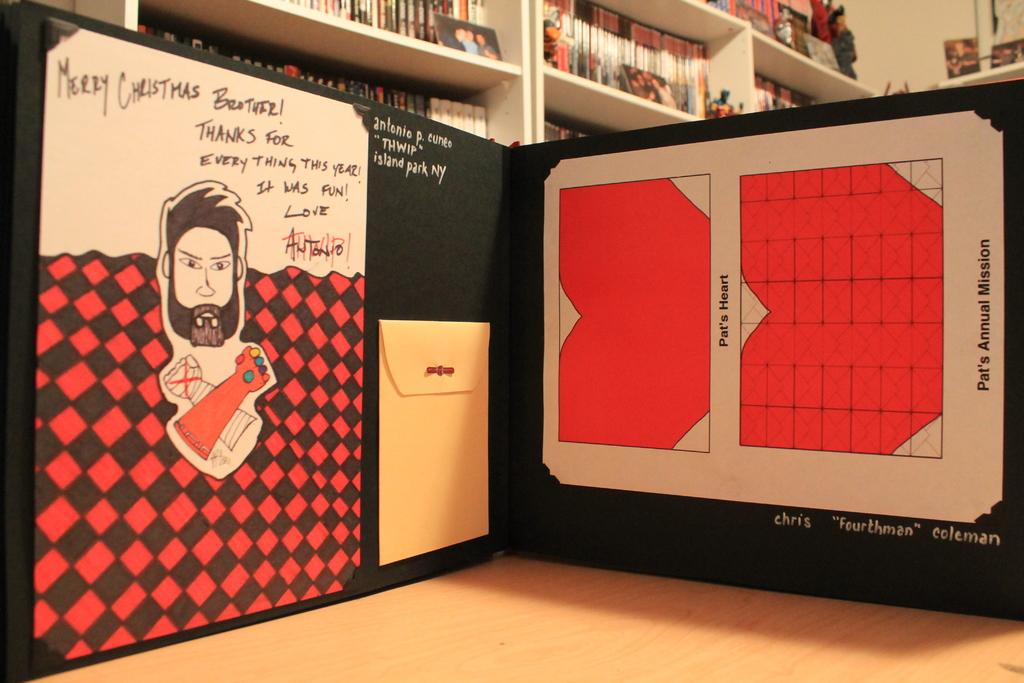Whose heart is shown on the exhibit on the right?
Provide a short and direct response. Pat's. What holiday is the note on the left for?
Keep it short and to the point. Christmas. 